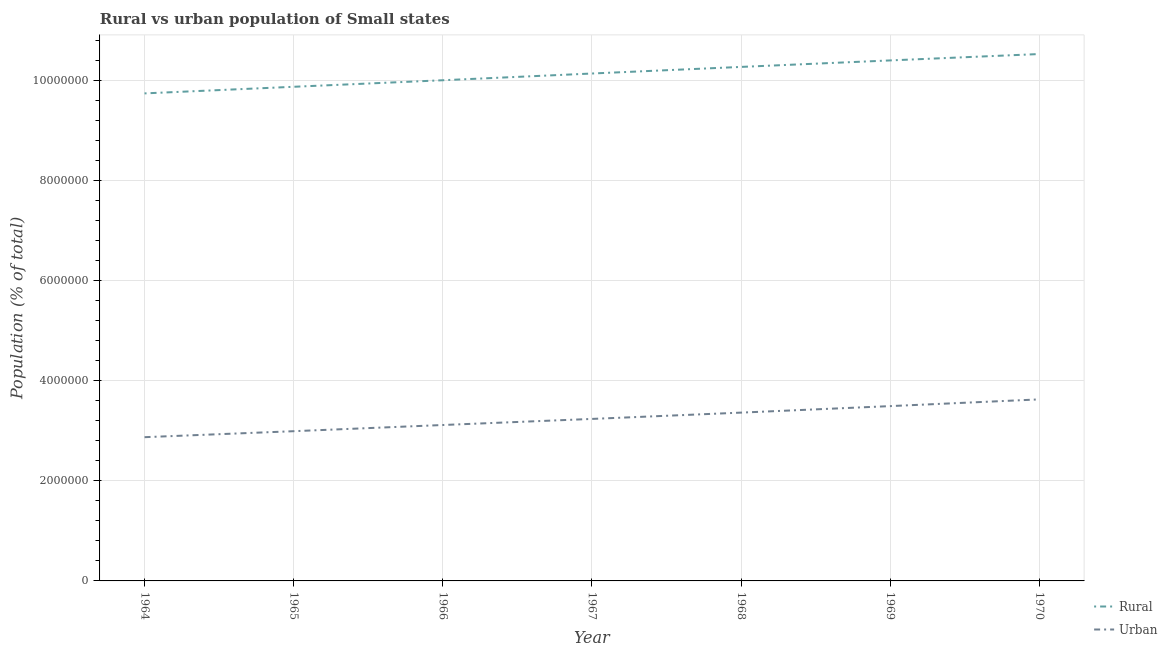How many different coloured lines are there?
Provide a short and direct response. 2. Does the line corresponding to urban population density intersect with the line corresponding to rural population density?
Keep it short and to the point. No. Is the number of lines equal to the number of legend labels?
Offer a terse response. Yes. What is the rural population density in 1968?
Offer a terse response. 1.03e+07. Across all years, what is the maximum urban population density?
Offer a terse response. 3.63e+06. Across all years, what is the minimum urban population density?
Provide a succinct answer. 2.87e+06. In which year was the rural population density minimum?
Offer a terse response. 1964. What is the total rural population density in the graph?
Your response must be concise. 7.10e+07. What is the difference between the urban population density in 1965 and that in 1966?
Give a very brief answer. -1.24e+05. What is the difference between the rural population density in 1969 and the urban population density in 1968?
Make the answer very short. 7.04e+06. What is the average rural population density per year?
Offer a very short reply. 1.01e+07. In the year 1965, what is the difference between the urban population density and rural population density?
Your answer should be very brief. -6.89e+06. What is the ratio of the urban population density in 1964 to that in 1966?
Ensure brevity in your answer.  0.92. Is the difference between the urban population density in 1965 and 1967 greater than the difference between the rural population density in 1965 and 1967?
Offer a very short reply. Yes. What is the difference between the highest and the second highest urban population density?
Provide a succinct answer. 1.34e+05. What is the difference between the highest and the lowest urban population density?
Ensure brevity in your answer.  7.56e+05. In how many years, is the urban population density greater than the average urban population density taken over all years?
Provide a succinct answer. 3. Is the sum of the rural population density in 1969 and 1970 greater than the maximum urban population density across all years?
Provide a succinct answer. Yes. What is the difference between two consecutive major ticks on the Y-axis?
Provide a succinct answer. 2.00e+06. What is the title of the graph?
Provide a succinct answer. Rural vs urban population of Small states. What is the label or title of the Y-axis?
Give a very brief answer. Population (% of total). What is the Population (% of total) in Rural in 1964?
Offer a very short reply. 9.75e+06. What is the Population (% of total) in Urban in 1964?
Your response must be concise. 2.87e+06. What is the Population (% of total) in Rural in 1965?
Provide a short and direct response. 9.88e+06. What is the Population (% of total) of Urban in 1965?
Ensure brevity in your answer.  2.99e+06. What is the Population (% of total) in Rural in 1966?
Keep it short and to the point. 1.00e+07. What is the Population (% of total) of Urban in 1966?
Ensure brevity in your answer.  3.12e+06. What is the Population (% of total) of Rural in 1967?
Provide a short and direct response. 1.01e+07. What is the Population (% of total) of Urban in 1967?
Keep it short and to the point. 3.24e+06. What is the Population (% of total) of Rural in 1968?
Your response must be concise. 1.03e+07. What is the Population (% of total) of Urban in 1968?
Your response must be concise. 3.37e+06. What is the Population (% of total) of Rural in 1969?
Provide a short and direct response. 1.04e+07. What is the Population (% of total) of Urban in 1969?
Give a very brief answer. 3.50e+06. What is the Population (% of total) in Rural in 1970?
Keep it short and to the point. 1.05e+07. What is the Population (% of total) of Urban in 1970?
Offer a very short reply. 3.63e+06. Across all years, what is the maximum Population (% of total) of Rural?
Keep it short and to the point. 1.05e+07. Across all years, what is the maximum Population (% of total) of Urban?
Your answer should be compact. 3.63e+06. Across all years, what is the minimum Population (% of total) in Rural?
Your answer should be compact. 9.75e+06. Across all years, what is the minimum Population (% of total) in Urban?
Offer a very short reply. 2.87e+06. What is the total Population (% of total) in Rural in the graph?
Keep it short and to the point. 7.10e+07. What is the total Population (% of total) of Urban in the graph?
Offer a very short reply. 2.27e+07. What is the difference between the Population (% of total) in Rural in 1964 and that in 1965?
Offer a very short reply. -1.32e+05. What is the difference between the Population (% of total) in Urban in 1964 and that in 1965?
Make the answer very short. -1.20e+05. What is the difference between the Population (% of total) in Rural in 1964 and that in 1966?
Provide a short and direct response. -2.63e+05. What is the difference between the Population (% of total) in Urban in 1964 and that in 1966?
Give a very brief answer. -2.43e+05. What is the difference between the Population (% of total) of Rural in 1964 and that in 1967?
Offer a very short reply. -3.98e+05. What is the difference between the Population (% of total) of Urban in 1964 and that in 1967?
Provide a succinct answer. -3.65e+05. What is the difference between the Population (% of total) in Rural in 1964 and that in 1968?
Keep it short and to the point. -5.30e+05. What is the difference between the Population (% of total) in Urban in 1964 and that in 1968?
Your answer should be very brief. -4.91e+05. What is the difference between the Population (% of total) in Rural in 1964 and that in 1969?
Your answer should be very brief. -6.60e+05. What is the difference between the Population (% of total) of Urban in 1964 and that in 1969?
Keep it short and to the point. -6.22e+05. What is the difference between the Population (% of total) of Rural in 1964 and that in 1970?
Your response must be concise. -7.87e+05. What is the difference between the Population (% of total) in Urban in 1964 and that in 1970?
Keep it short and to the point. -7.56e+05. What is the difference between the Population (% of total) in Rural in 1965 and that in 1966?
Offer a terse response. -1.31e+05. What is the difference between the Population (% of total) in Urban in 1965 and that in 1966?
Your answer should be very brief. -1.24e+05. What is the difference between the Population (% of total) of Rural in 1965 and that in 1967?
Offer a terse response. -2.65e+05. What is the difference between the Population (% of total) of Urban in 1965 and that in 1967?
Give a very brief answer. -2.46e+05. What is the difference between the Population (% of total) in Rural in 1965 and that in 1968?
Offer a very short reply. -3.97e+05. What is the difference between the Population (% of total) in Urban in 1965 and that in 1968?
Give a very brief answer. -3.72e+05. What is the difference between the Population (% of total) of Rural in 1965 and that in 1969?
Offer a terse response. -5.27e+05. What is the difference between the Population (% of total) of Urban in 1965 and that in 1969?
Make the answer very short. -5.02e+05. What is the difference between the Population (% of total) in Rural in 1965 and that in 1970?
Your answer should be very brief. -6.55e+05. What is the difference between the Population (% of total) in Urban in 1965 and that in 1970?
Give a very brief answer. -6.36e+05. What is the difference between the Population (% of total) of Rural in 1966 and that in 1967?
Ensure brevity in your answer.  -1.35e+05. What is the difference between the Population (% of total) in Urban in 1966 and that in 1967?
Your answer should be compact. -1.22e+05. What is the difference between the Population (% of total) in Rural in 1966 and that in 1968?
Your answer should be compact. -2.67e+05. What is the difference between the Population (% of total) of Urban in 1966 and that in 1968?
Provide a short and direct response. -2.48e+05. What is the difference between the Population (% of total) of Rural in 1966 and that in 1969?
Ensure brevity in your answer.  -3.97e+05. What is the difference between the Population (% of total) of Urban in 1966 and that in 1969?
Ensure brevity in your answer.  -3.78e+05. What is the difference between the Population (% of total) in Rural in 1966 and that in 1970?
Offer a terse response. -5.24e+05. What is the difference between the Population (% of total) in Urban in 1966 and that in 1970?
Keep it short and to the point. -5.12e+05. What is the difference between the Population (% of total) of Rural in 1967 and that in 1968?
Give a very brief answer. -1.32e+05. What is the difference between the Population (% of total) in Urban in 1967 and that in 1968?
Make the answer very short. -1.26e+05. What is the difference between the Population (% of total) of Rural in 1967 and that in 1969?
Ensure brevity in your answer.  -2.62e+05. What is the difference between the Population (% of total) of Urban in 1967 and that in 1969?
Ensure brevity in your answer.  -2.56e+05. What is the difference between the Population (% of total) in Rural in 1967 and that in 1970?
Make the answer very short. -3.90e+05. What is the difference between the Population (% of total) of Urban in 1967 and that in 1970?
Your response must be concise. -3.91e+05. What is the difference between the Population (% of total) in Rural in 1968 and that in 1969?
Keep it short and to the point. -1.30e+05. What is the difference between the Population (% of total) in Urban in 1968 and that in 1969?
Keep it short and to the point. -1.30e+05. What is the difference between the Population (% of total) in Rural in 1968 and that in 1970?
Give a very brief answer. -2.58e+05. What is the difference between the Population (% of total) in Urban in 1968 and that in 1970?
Provide a succinct answer. -2.65e+05. What is the difference between the Population (% of total) in Rural in 1969 and that in 1970?
Offer a very short reply. -1.28e+05. What is the difference between the Population (% of total) in Urban in 1969 and that in 1970?
Your response must be concise. -1.34e+05. What is the difference between the Population (% of total) in Rural in 1964 and the Population (% of total) in Urban in 1965?
Offer a very short reply. 6.76e+06. What is the difference between the Population (% of total) in Rural in 1964 and the Population (% of total) in Urban in 1966?
Offer a terse response. 6.63e+06. What is the difference between the Population (% of total) of Rural in 1964 and the Population (% of total) of Urban in 1967?
Your answer should be very brief. 6.51e+06. What is the difference between the Population (% of total) in Rural in 1964 and the Population (% of total) in Urban in 1968?
Make the answer very short. 6.38e+06. What is the difference between the Population (% of total) of Rural in 1964 and the Population (% of total) of Urban in 1969?
Ensure brevity in your answer.  6.25e+06. What is the difference between the Population (% of total) of Rural in 1964 and the Population (% of total) of Urban in 1970?
Your response must be concise. 6.12e+06. What is the difference between the Population (% of total) in Rural in 1965 and the Population (% of total) in Urban in 1966?
Your response must be concise. 6.76e+06. What is the difference between the Population (% of total) of Rural in 1965 and the Population (% of total) of Urban in 1967?
Offer a very short reply. 6.64e+06. What is the difference between the Population (% of total) in Rural in 1965 and the Population (% of total) in Urban in 1968?
Make the answer very short. 6.52e+06. What is the difference between the Population (% of total) of Rural in 1965 and the Population (% of total) of Urban in 1969?
Offer a terse response. 6.39e+06. What is the difference between the Population (% of total) of Rural in 1965 and the Population (% of total) of Urban in 1970?
Keep it short and to the point. 6.25e+06. What is the difference between the Population (% of total) in Rural in 1966 and the Population (% of total) in Urban in 1967?
Offer a very short reply. 6.77e+06. What is the difference between the Population (% of total) in Rural in 1966 and the Population (% of total) in Urban in 1968?
Ensure brevity in your answer.  6.65e+06. What is the difference between the Population (% of total) of Rural in 1966 and the Population (% of total) of Urban in 1969?
Make the answer very short. 6.52e+06. What is the difference between the Population (% of total) in Rural in 1966 and the Population (% of total) in Urban in 1970?
Your response must be concise. 6.38e+06. What is the difference between the Population (% of total) of Rural in 1967 and the Population (% of total) of Urban in 1968?
Ensure brevity in your answer.  6.78e+06. What is the difference between the Population (% of total) in Rural in 1967 and the Population (% of total) in Urban in 1969?
Your answer should be compact. 6.65e+06. What is the difference between the Population (% of total) in Rural in 1967 and the Population (% of total) in Urban in 1970?
Provide a short and direct response. 6.52e+06. What is the difference between the Population (% of total) in Rural in 1968 and the Population (% of total) in Urban in 1969?
Give a very brief answer. 6.78e+06. What is the difference between the Population (% of total) of Rural in 1968 and the Population (% of total) of Urban in 1970?
Provide a succinct answer. 6.65e+06. What is the difference between the Population (% of total) in Rural in 1969 and the Population (% of total) in Urban in 1970?
Provide a succinct answer. 6.78e+06. What is the average Population (% of total) in Rural per year?
Ensure brevity in your answer.  1.01e+07. What is the average Population (% of total) in Urban per year?
Make the answer very short. 3.25e+06. In the year 1964, what is the difference between the Population (% of total) of Rural and Population (% of total) of Urban?
Give a very brief answer. 6.88e+06. In the year 1965, what is the difference between the Population (% of total) of Rural and Population (% of total) of Urban?
Provide a short and direct response. 6.89e+06. In the year 1966, what is the difference between the Population (% of total) in Rural and Population (% of total) in Urban?
Make the answer very short. 6.89e+06. In the year 1967, what is the difference between the Population (% of total) of Rural and Population (% of total) of Urban?
Provide a succinct answer. 6.91e+06. In the year 1968, what is the difference between the Population (% of total) of Rural and Population (% of total) of Urban?
Offer a terse response. 6.91e+06. In the year 1969, what is the difference between the Population (% of total) of Rural and Population (% of total) of Urban?
Your answer should be very brief. 6.91e+06. In the year 1970, what is the difference between the Population (% of total) of Rural and Population (% of total) of Urban?
Your answer should be very brief. 6.91e+06. What is the ratio of the Population (% of total) in Rural in 1964 to that in 1965?
Ensure brevity in your answer.  0.99. What is the ratio of the Population (% of total) in Urban in 1964 to that in 1965?
Your answer should be very brief. 0.96. What is the ratio of the Population (% of total) of Rural in 1964 to that in 1966?
Provide a short and direct response. 0.97. What is the ratio of the Population (% of total) of Urban in 1964 to that in 1966?
Give a very brief answer. 0.92. What is the ratio of the Population (% of total) in Rural in 1964 to that in 1967?
Keep it short and to the point. 0.96. What is the ratio of the Population (% of total) of Urban in 1964 to that in 1967?
Keep it short and to the point. 0.89. What is the ratio of the Population (% of total) of Rural in 1964 to that in 1968?
Give a very brief answer. 0.95. What is the ratio of the Population (% of total) in Urban in 1964 to that in 1968?
Ensure brevity in your answer.  0.85. What is the ratio of the Population (% of total) in Rural in 1964 to that in 1969?
Ensure brevity in your answer.  0.94. What is the ratio of the Population (% of total) in Urban in 1964 to that in 1969?
Your response must be concise. 0.82. What is the ratio of the Population (% of total) of Rural in 1964 to that in 1970?
Keep it short and to the point. 0.93. What is the ratio of the Population (% of total) of Urban in 1964 to that in 1970?
Give a very brief answer. 0.79. What is the ratio of the Population (% of total) of Rural in 1965 to that in 1966?
Provide a short and direct response. 0.99. What is the ratio of the Population (% of total) in Urban in 1965 to that in 1966?
Provide a short and direct response. 0.96. What is the ratio of the Population (% of total) of Rural in 1965 to that in 1967?
Your response must be concise. 0.97. What is the ratio of the Population (% of total) in Urban in 1965 to that in 1967?
Offer a very short reply. 0.92. What is the ratio of the Population (% of total) in Rural in 1965 to that in 1968?
Provide a succinct answer. 0.96. What is the ratio of the Population (% of total) of Urban in 1965 to that in 1968?
Offer a terse response. 0.89. What is the ratio of the Population (% of total) of Rural in 1965 to that in 1969?
Give a very brief answer. 0.95. What is the ratio of the Population (% of total) of Urban in 1965 to that in 1969?
Make the answer very short. 0.86. What is the ratio of the Population (% of total) in Rural in 1965 to that in 1970?
Your answer should be compact. 0.94. What is the ratio of the Population (% of total) in Urban in 1965 to that in 1970?
Your response must be concise. 0.82. What is the ratio of the Population (% of total) in Rural in 1966 to that in 1967?
Give a very brief answer. 0.99. What is the ratio of the Population (% of total) in Urban in 1966 to that in 1967?
Offer a very short reply. 0.96. What is the ratio of the Population (% of total) of Rural in 1966 to that in 1968?
Provide a short and direct response. 0.97. What is the ratio of the Population (% of total) in Urban in 1966 to that in 1968?
Provide a succinct answer. 0.93. What is the ratio of the Population (% of total) of Rural in 1966 to that in 1969?
Offer a very short reply. 0.96. What is the ratio of the Population (% of total) of Urban in 1966 to that in 1969?
Make the answer very short. 0.89. What is the ratio of the Population (% of total) in Rural in 1966 to that in 1970?
Your answer should be very brief. 0.95. What is the ratio of the Population (% of total) in Urban in 1966 to that in 1970?
Your answer should be very brief. 0.86. What is the ratio of the Population (% of total) of Rural in 1967 to that in 1968?
Provide a succinct answer. 0.99. What is the ratio of the Population (% of total) in Urban in 1967 to that in 1968?
Your answer should be compact. 0.96. What is the ratio of the Population (% of total) of Rural in 1967 to that in 1969?
Ensure brevity in your answer.  0.97. What is the ratio of the Population (% of total) of Urban in 1967 to that in 1969?
Keep it short and to the point. 0.93. What is the ratio of the Population (% of total) of Urban in 1967 to that in 1970?
Provide a short and direct response. 0.89. What is the ratio of the Population (% of total) of Rural in 1968 to that in 1969?
Offer a terse response. 0.99. What is the ratio of the Population (% of total) of Urban in 1968 to that in 1969?
Give a very brief answer. 0.96. What is the ratio of the Population (% of total) of Rural in 1968 to that in 1970?
Keep it short and to the point. 0.98. What is the ratio of the Population (% of total) in Urban in 1968 to that in 1970?
Keep it short and to the point. 0.93. What is the ratio of the Population (% of total) in Rural in 1969 to that in 1970?
Make the answer very short. 0.99. What is the difference between the highest and the second highest Population (% of total) in Rural?
Offer a terse response. 1.28e+05. What is the difference between the highest and the second highest Population (% of total) in Urban?
Offer a very short reply. 1.34e+05. What is the difference between the highest and the lowest Population (% of total) of Rural?
Your answer should be compact. 7.87e+05. What is the difference between the highest and the lowest Population (% of total) in Urban?
Provide a short and direct response. 7.56e+05. 